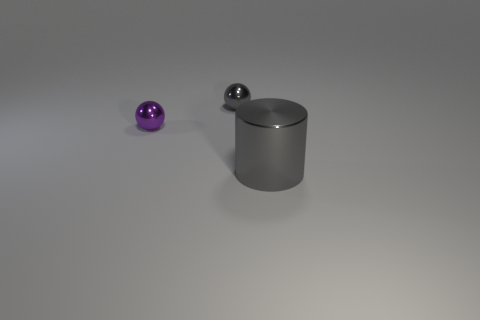What number of other small metallic things are the same shape as the small gray object?
Ensure brevity in your answer.  1. Does the tiny gray object have the same shape as the large gray metallic thing?
Give a very brief answer. No. What number of objects are gray objects that are on the left side of the large shiny cylinder or metal objects?
Keep it short and to the point. 3. What is the shape of the gray metallic object that is to the left of the gray metal object in front of the gray metallic thing on the left side of the big gray cylinder?
Your answer should be very brief. Sphere. What shape is the tiny purple thing that is made of the same material as the small gray object?
Provide a short and direct response. Sphere. How big is the gray metallic cylinder?
Offer a terse response. Large. Do the purple object and the gray metal ball have the same size?
Provide a succinct answer. Yes. What number of objects are either small purple balls that are to the left of the large metallic thing or gray objects on the left side of the big gray thing?
Provide a succinct answer. 2. There is a gray metal object behind the metal cylinder on the right side of the small purple metal sphere; how many large gray metallic cylinders are on the left side of it?
Make the answer very short. 0. There is a ball that is behind the purple metal object; how big is it?
Make the answer very short. Small. 